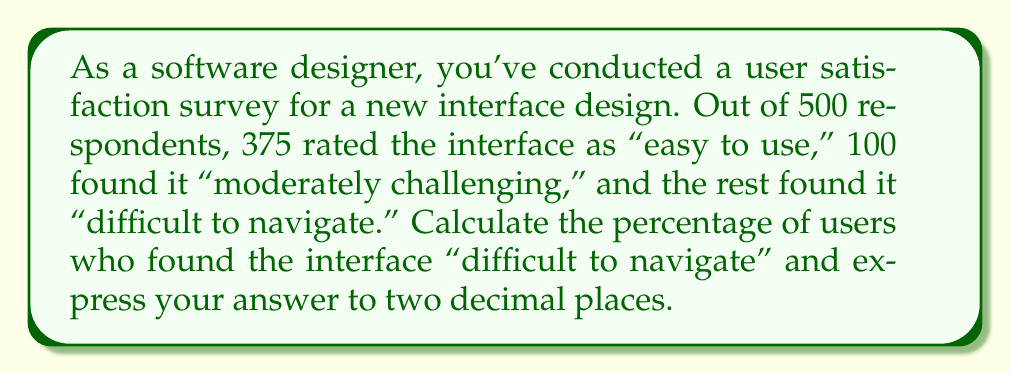Show me your answer to this math problem. To solve this problem, we'll follow these steps:

1. Determine the number of users who found the interface "difficult to navigate":
   - Total respondents: 500
   - Users who rated it "easy to use": 375
   - Users who found it "moderately challenging": 100
   - Users who found it "difficult to navigate": $500 - 375 - 100 = 25$

2. Calculate the percentage:
   Let $x$ be the percentage of users who found the interface "difficult to navigate".
   
   $$x = \frac{\text{Number of users who found it difficult}}{\text{Total number of respondents}} \times 100\%$$
   
   $$x = \frac{25}{500} \times 100\%$$

3. Simplify the fraction:
   $$x = \frac{1}{20} \times 100\%$$

4. Perform the multiplication:
   $$x = 5\%$$

5. Express the answer to two decimal places:
   The percentage is already in its simplest form with no decimal places, so it remains 5.00%.
Answer: 5.00% 